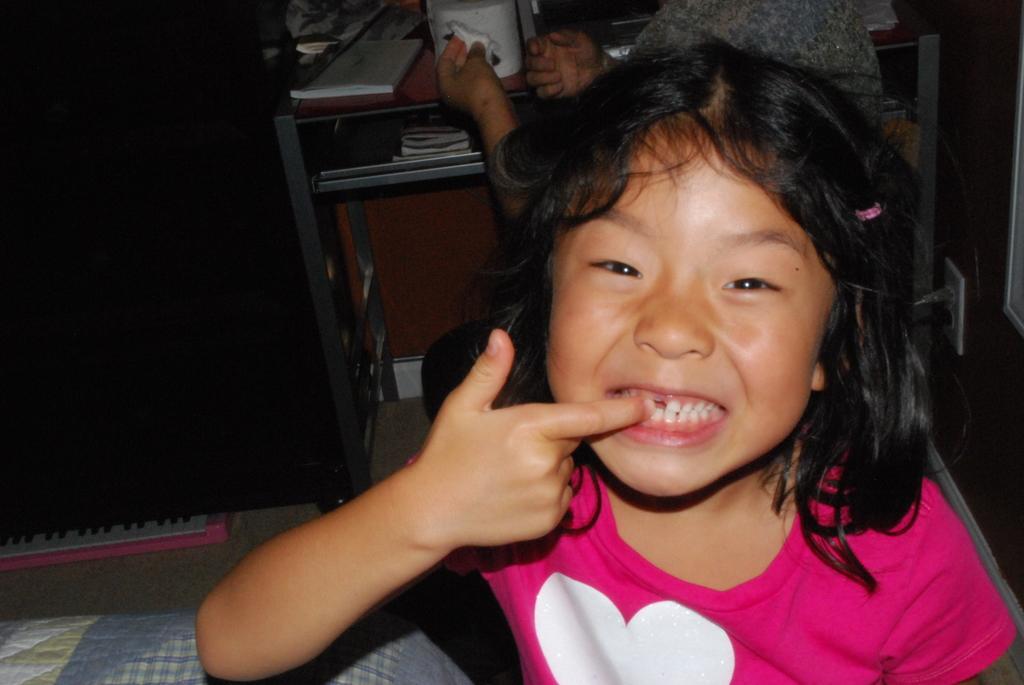Could you give a brief overview of what you see in this image? In the foreground of the picture we can see a girl, cloth and wall. At the top we can see desk, books, person and other objects. 